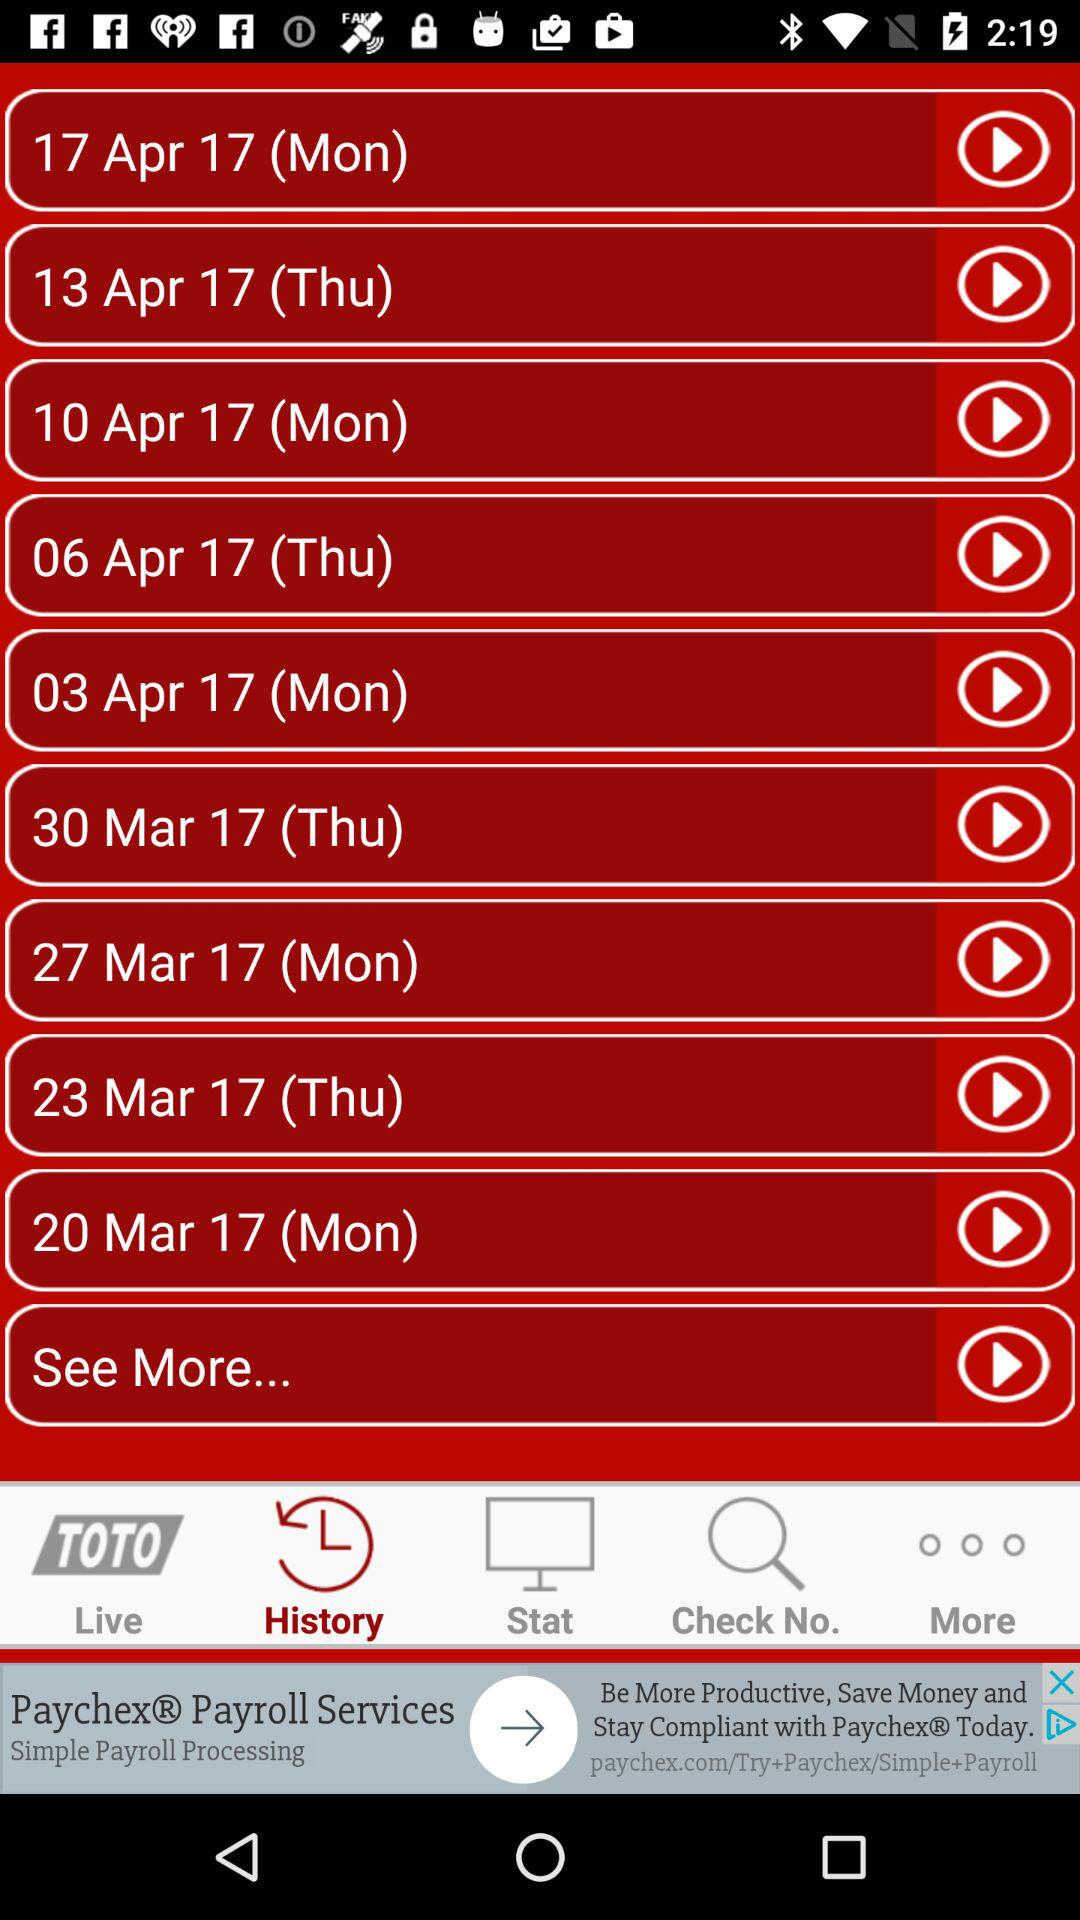Which tab is selected? The selected tab is "History". 